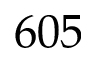Convert formula to latex. <formula><loc_0><loc_0><loc_500><loc_500>6 0 5</formula> 